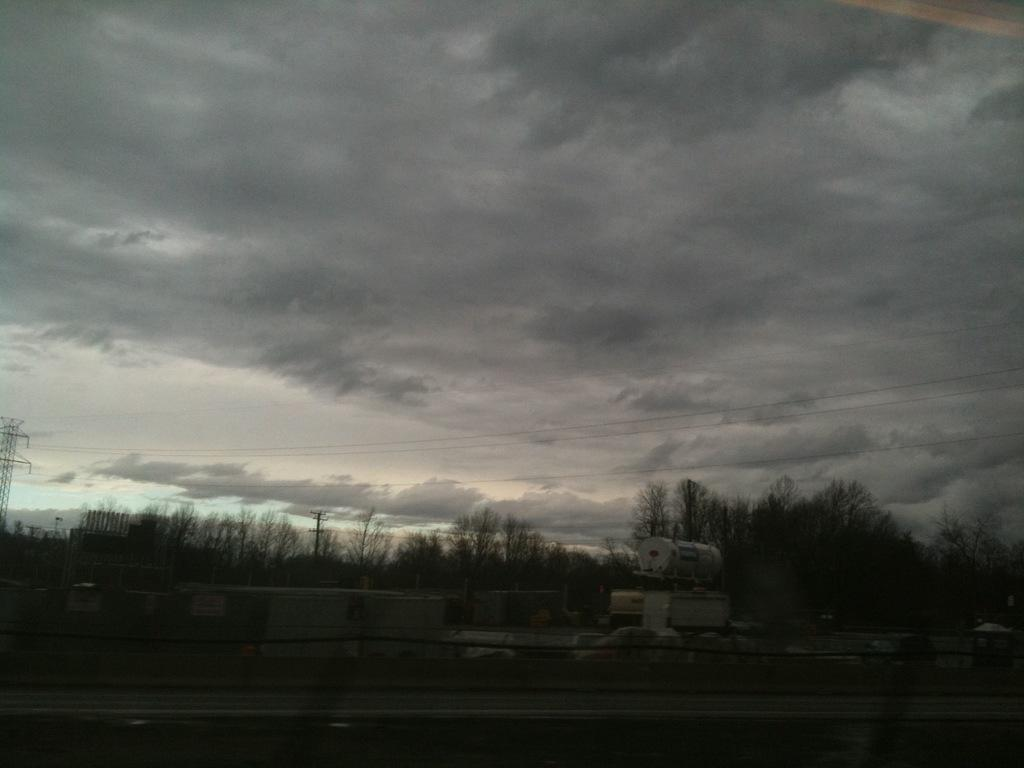What is the main feature of the image? There is a road in the image. What is located behind the road? There is road fencing behind the road. What else can be seen on the road? Vehicles are present in the image. What is visible behind the vehicles? Trees are visible behind the vehicles. What other objects are present in the image? Poles are present in the image. What is attached to the poles? Electric wires are visible in the image. How would you describe the sky in the image? The sky is full of clouds. What type of butter is being used to grease the window in the image? There is no butter or window present in the image. How many dimes can be seen on the electric wires in the image? There are no dimes present on the electric wires in the image. 